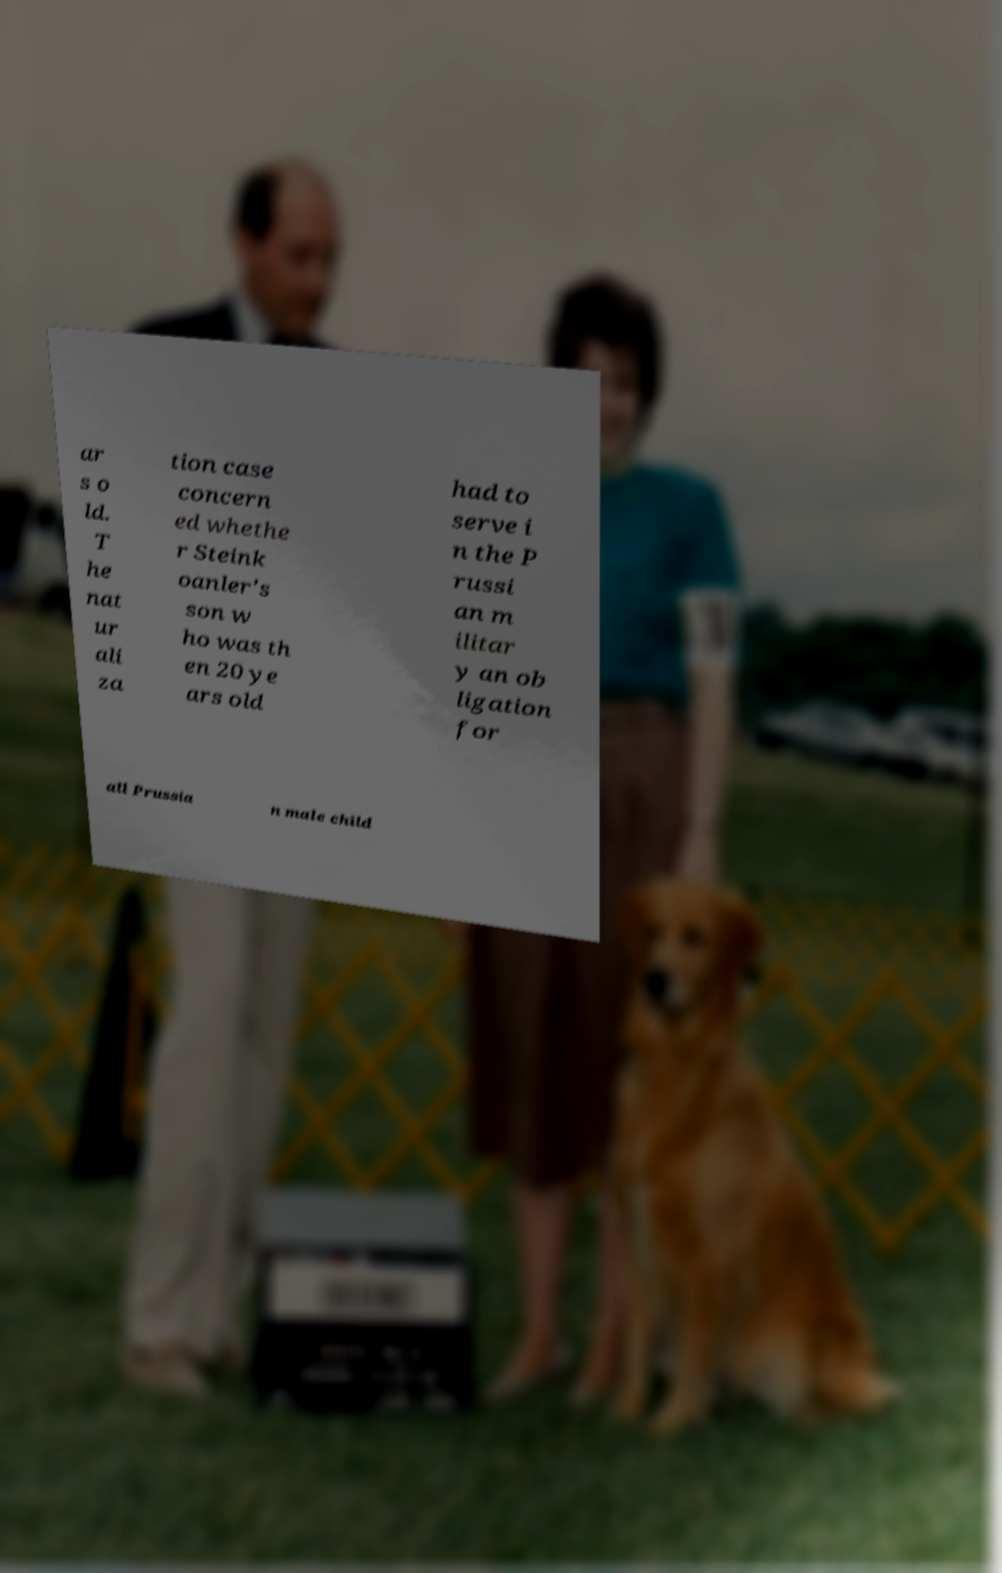Can you accurately transcribe the text from the provided image for me? ar s o ld. T he nat ur ali za tion case concern ed whethe r Steink oanler's son w ho was th en 20 ye ars old had to serve i n the P russi an m ilitar y an ob ligation for all Prussia n male child 